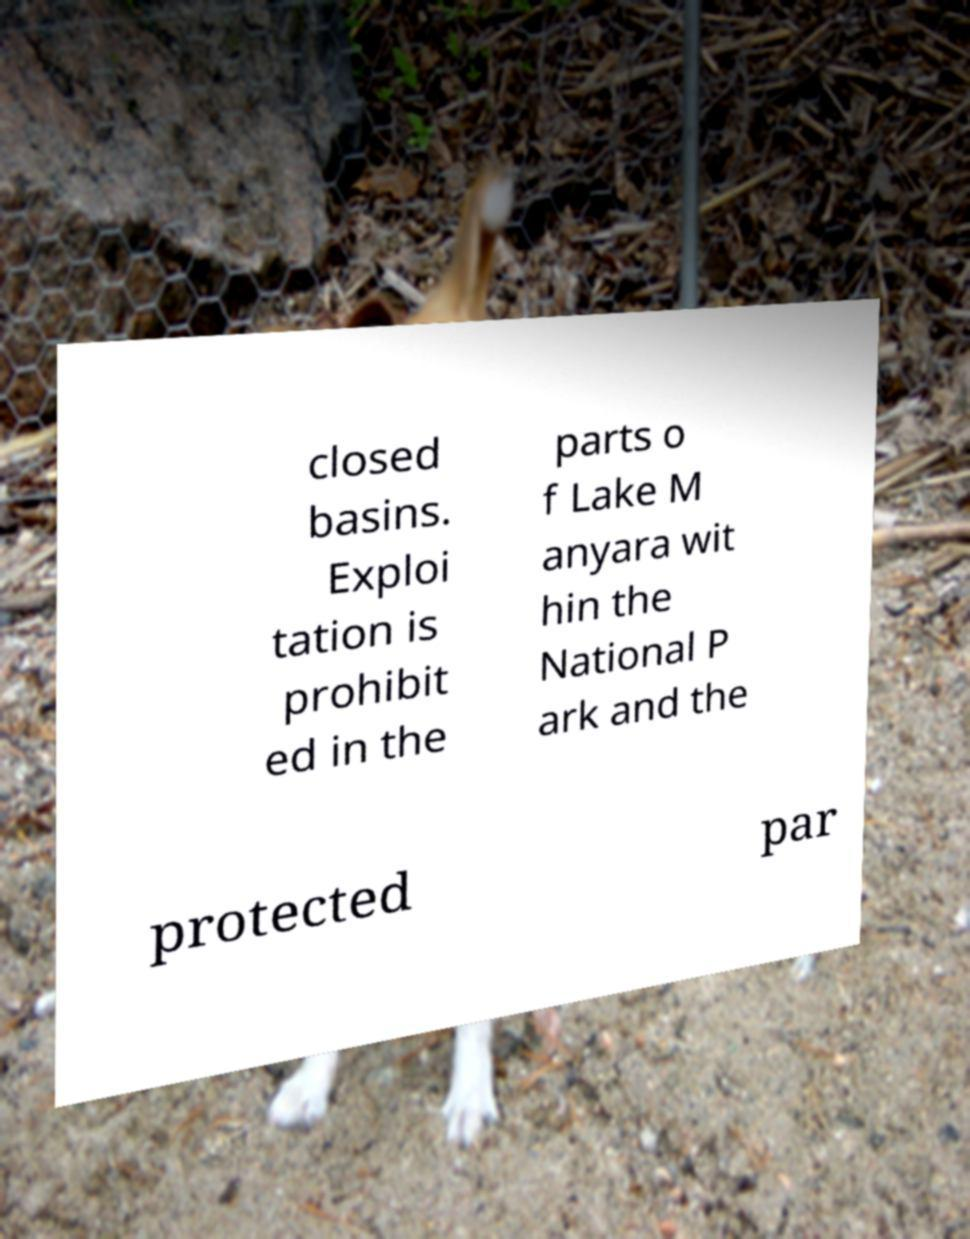There's text embedded in this image that I need extracted. Can you transcribe it verbatim? closed basins. Exploi tation is prohibit ed in the parts o f Lake M anyara wit hin the National P ark and the protected par 